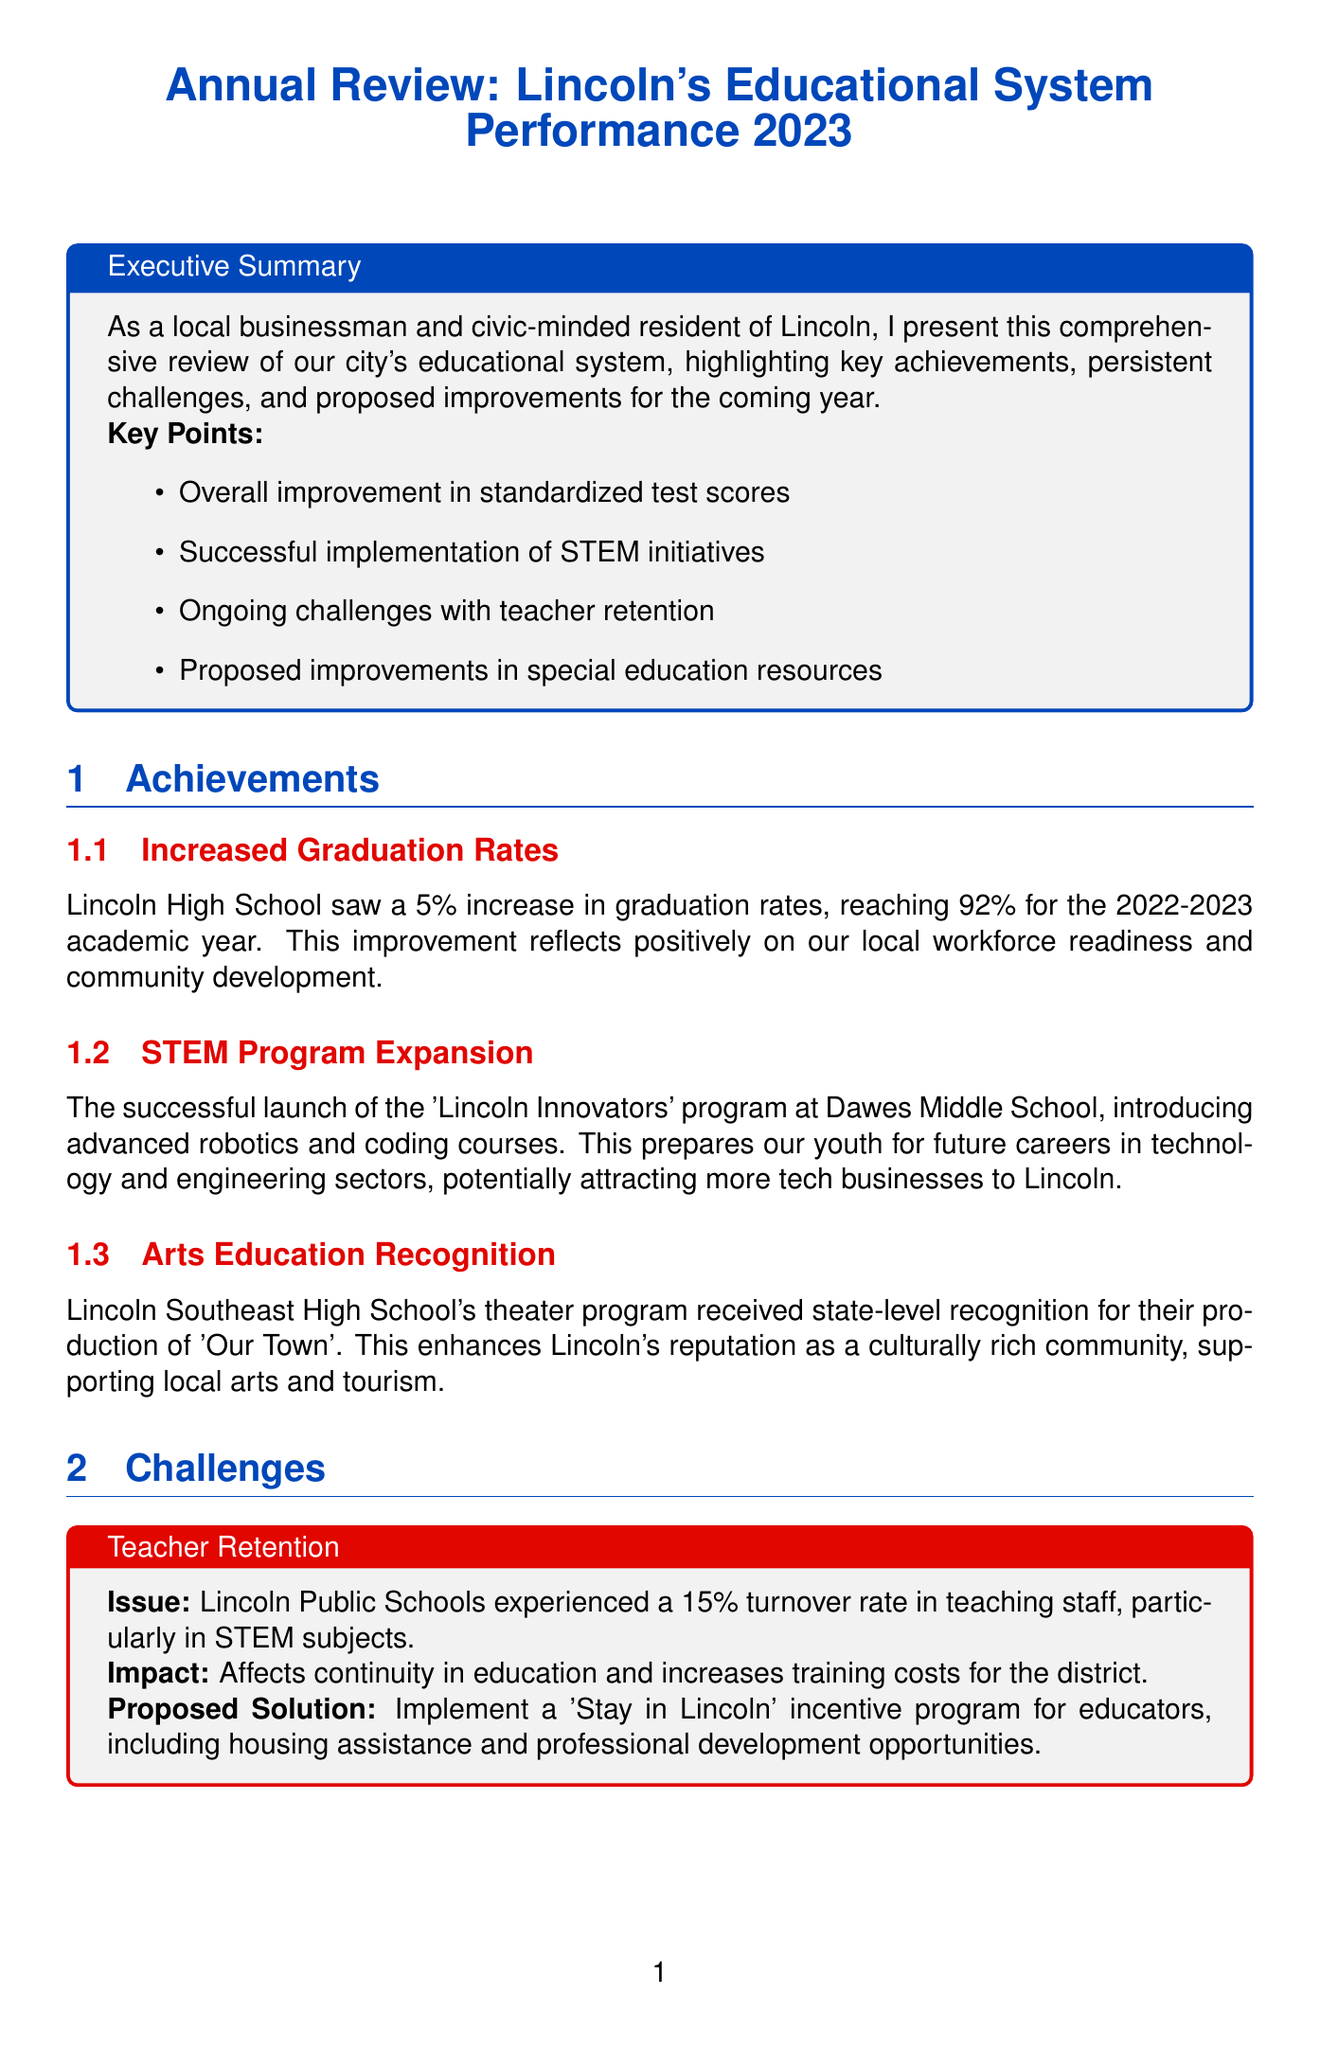what was the increase in graduation rates at Lincoln High School? The graduation rates increased by 5%, reaching 92% for the 2022-2023 academic year.
Answer: 5% what is the name of the program launched at Dawes Middle School? The program launched is called 'Lincoln Innovators'.
Answer: Lincoln Innovators what percentage of students lack reliable internet access at home? Approximately 20% of students in Lincoln Public Schools lack reliable internet access at home.
Answer: 20% what is the proposed solution for teacher retention issues? The proposed solution is to implement a 'Stay in Lincoln' incentive program for educators.
Answer: Stay in Lincoln incentive program which high school received state-level recognition for its theater program? Lincoln Southeast High School received state-level recognition for their production.
Answer: Lincoln Southeast High School what is the expected outcome of increasing funding for special education programs? The expected outcome is improved support for students with diverse learning needs.
Answer: Improved support for students how many new CTE courses are proposed to be introduced at Lincoln North Star High School? The document mentions introducing new CTE courses, but does not specify a number.
Answer: Not specified what initiative encourages local businesses to participate in mentorship programs? The initiative is called 'Lincoln Learns Together'.
Answer: Lincoln Learns Together what is one proposed improvement related to infrastructure? One proposed improvement is to initiate a public-private partnership for school renovation projects.
Answer: Public-private partnership for renovations 